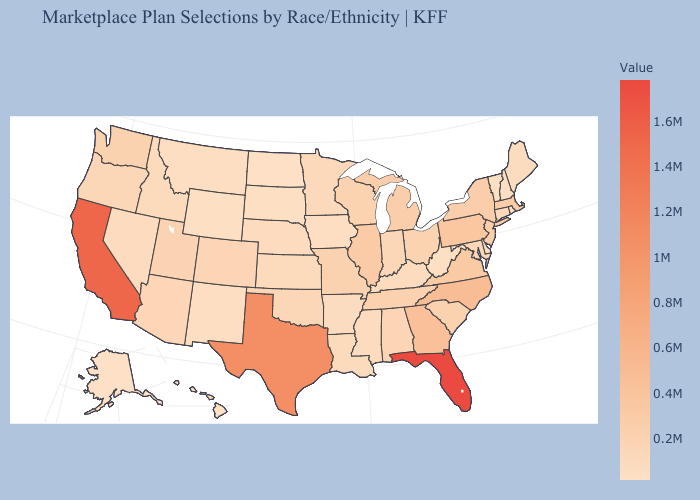Which states hav the highest value in the West?
Give a very brief answer. California. Among the states that border Arizona , does Utah have the lowest value?
Keep it brief. No. Does New Mexico have the lowest value in the USA?
Give a very brief answer. No. Among the states that border Connecticut , which have the highest value?
Write a very short answer. Massachusetts. Does Alaska have the lowest value in the West?
Answer briefly. Yes. 